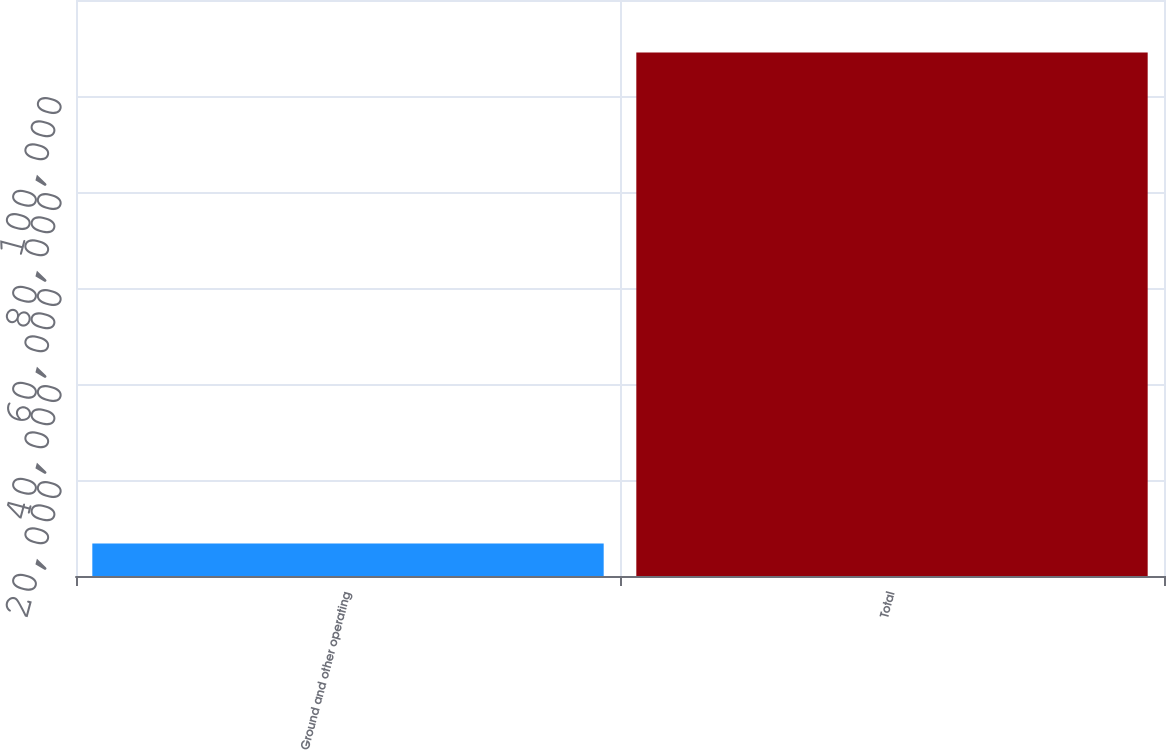<chart> <loc_0><loc_0><loc_500><loc_500><bar_chart><fcel>Ground and other operating<fcel>Total<nl><fcel>6756<fcel>109078<nl></chart> 